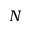<formula> <loc_0><loc_0><loc_500><loc_500>N</formula> 